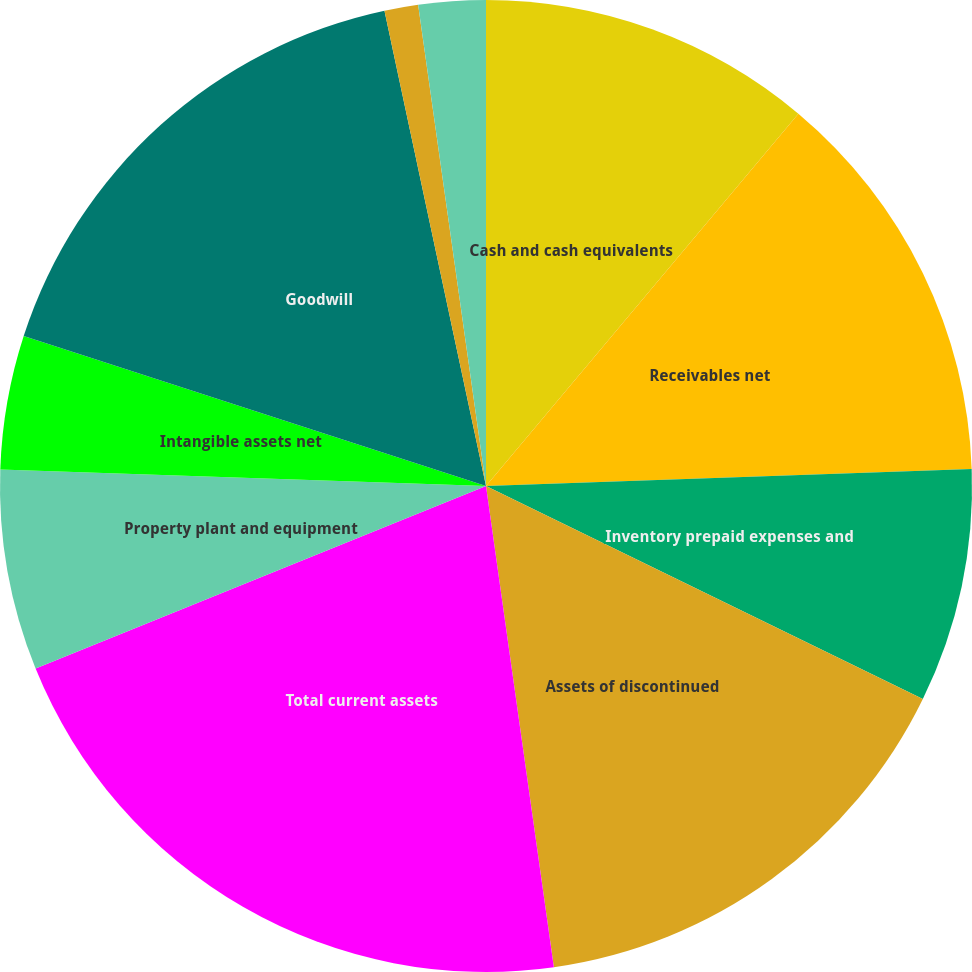<chart> <loc_0><loc_0><loc_500><loc_500><pie_chart><fcel>Cash and cash equivalents<fcel>Receivables net<fcel>Inventory prepaid expenses and<fcel>Assets of discontinued<fcel>Total current assets<fcel>Property plant and equipment<fcel>Intangible assets net<fcel>Goodwill<fcel>Deferred income taxes<fcel>Other assets<nl><fcel>11.11%<fcel>13.33%<fcel>7.78%<fcel>15.55%<fcel>21.1%<fcel>6.67%<fcel>4.45%<fcel>16.66%<fcel>1.12%<fcel>2.23%<nl></chart> 